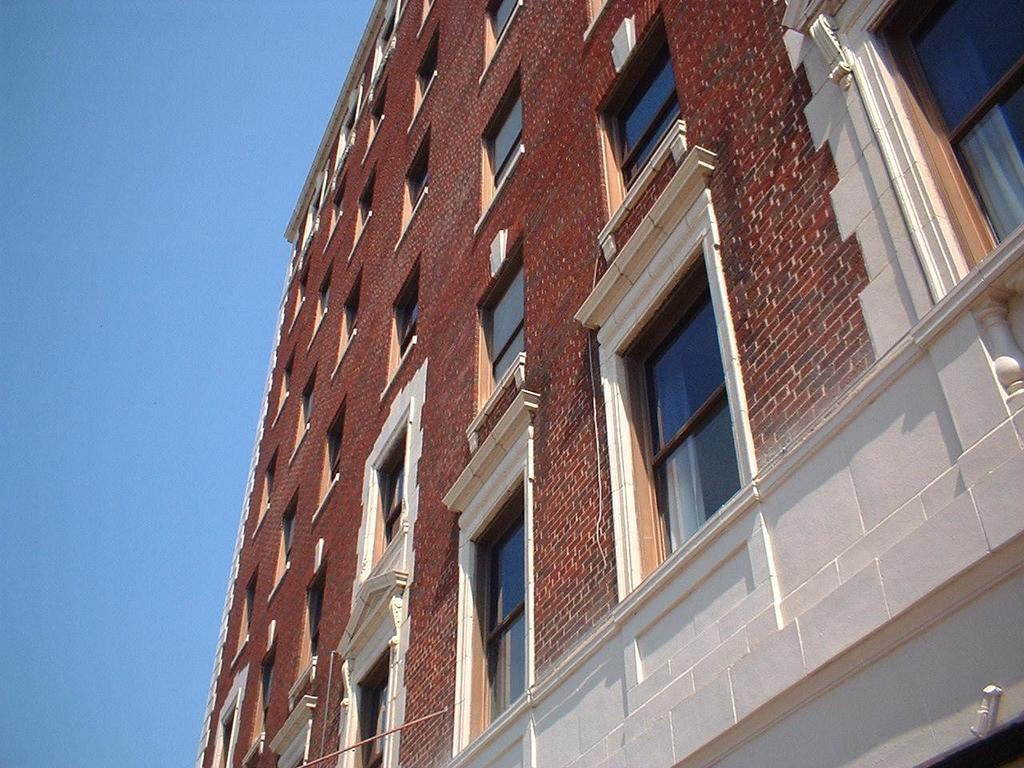What type of structure is present in the image? There is a building in the picture. What material is used for the windows of the building? The building has glass windows. What is the primary material used for the walls of the building? The building has brick walls. What can be seen in the sky in the image? There are clouds in the sky. Can you tell me which band is performing on the roof of the building in the image? There is no band performing on the roof of the building in the image. Is the queen present in the image, standing next to the building? There is no queen present in the image. How many hens can be seen in the image, near the building? There are no hens present in the image. 